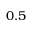Convert formula to latex. <formula><loc_0><loc_0><loc_500><loc_500>0 . 5</formula> 